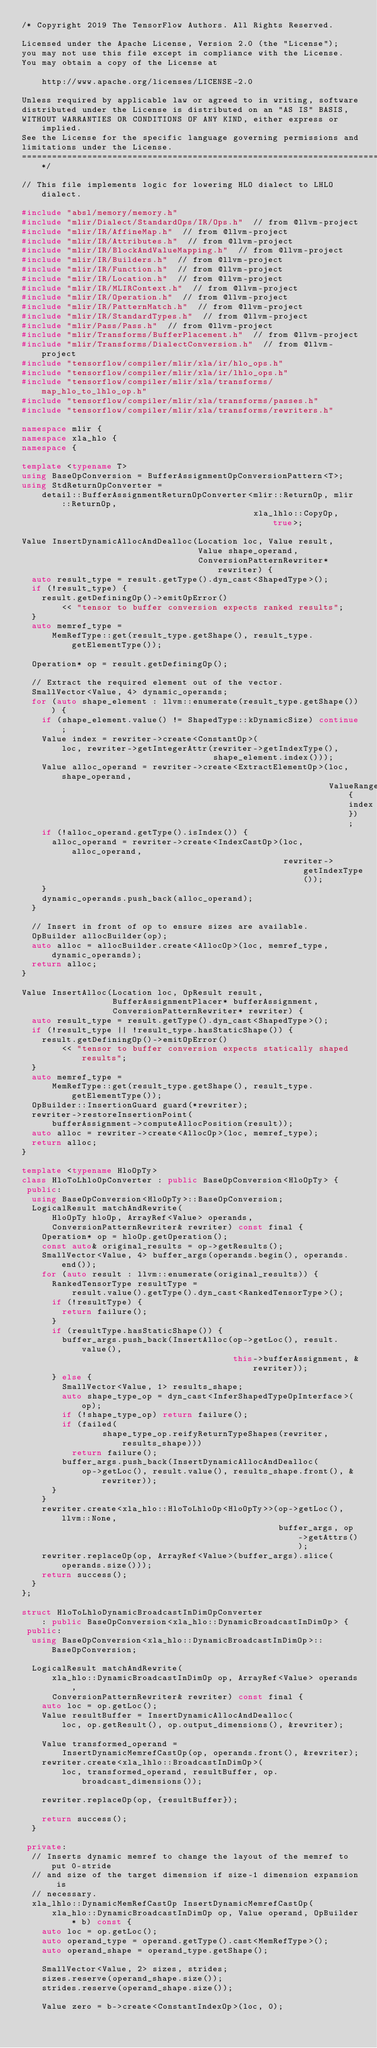<code> <loc_0><loc_0><loc_500><loc_500><_C++_>/* Copyright 2019 The TensorFlow Authors. All Rights Reserved.

Licensed under the Apache License, Version 2.0 (the "License");
you may not use this file except in compliance with the License.
You may obtain a copy of the License at

    http://www.apache.org/licenses/LICENSE-2.0

Unless required by applicable law or agreed to in writing, software
distributed under the License is distributed on an "AS IS" BASIS,
WITHOUT WARRANTIES OR CONDITIONS OF ANY KIND, either express or implied.
See the License for the specific language governing permissions and
limitations under the License.
==============================================================================*/

// This file implements logic for lowering HLO dialect to LHLO dialect.

#include "absl/memory/memory.h"
#include "mlir/Dialect/StandardOps/IR/Ops.h"  // from @llvm-project
#include "mlir/IR/AffineMap.h"  // from @llvm-project
#include "mlir/IR/Attributes.h"  // from @llvm-project
#include "mlir/IR/BlockAndValueMapping.h"  // from @llvm-project
#include "mlir/IR/Builders.h"  // from @llvm-project
#include "mlir/IR/Function.h"  // from @llvm-project
#include "mlir/IR/Location.h"  // from @llvm-project
#include "mlir/IR/MLIRContext.h"  // from @llvm-project
#include "mlir/IR/Operation.h"  // from @llvm-project
#include "mlir/IR/PatternMatch.h"  // from @llvm-project
#include "mlir/IR/StandardTypes.h"  // from @llvm-project
#include "mlir/Pass/Pass.h"  // from @llvm-project
#include "mlir/Transforms/BufferPlacement.h"  // from @llvm-project
#include "mlir/Transforms/DialectConversion.h"  // from @llvm-project
#include "tensorflow/compiler/mlir/xla/ir/hlo_ops.h"
#include "tensorflow/compiler/mlir/xla/ir/lhlo_ops.h"
#include "tensorflow/compiler/mlir/xla/transforms/map_hlo_to_lhlo_op.h"
#include "tensorflow/compiler/mlir/xla/transforms/passes.h"
#include "tensorflow/compiler/mlir/xla/transforms/rewriters.h"

namespace mlir {
namespace xla_hlo {
namespace {

template <typename T>
using BaseOpConversion = BufferAssignmentOpConversionPattern<T>;
using StdReturnOpConverter =
    detail::BufferAssignmentReturnOpConverter<mlir::ReturnOp, mlir::ReturnOp,
                                              xla_lhlo::CopyOp, true>;

Value InsertDynamicAllocAndDealloc(Location loc, Value result,
                                   Value shape_operand,
                                   ConversionPatternRewriter* rewriter) {
  auto result_type = result.getType().dyn_cast<ShapedType>();
  if (!result_type) {
    result.getDefiningOp()->emitOpError()
        << "tensor to buffer conversion expects ranked results";
  }
  auto memref_type =
      MemRefType::get(result_type.getShape(), result_type.getElementType());

  Operation* op = result.getDefiningOp();

  // Extract the required element out of the vector.
  SmallVector<Value, 4> dynamic_operands;
  for (auto shape_element : llvm::enumerate(result_type.getShape())) {
    if (shape_element.value() != ShapedType::kDynamicSize) continue;
    Value index = rewriter->create<ConstantOp>(
        loc, rewriter->getIntegerAttr(rewriter->getIndexType(),
                                      shape_element.index()));
    Value alloc_operand = rewriter->create<ExtractElementOp>(loc, shape_operand,
                                                             ValueRange{index});
    if (!alloc_operand.getType().isIndex()) {
      alloc_operand = rewriter->create<IndexCastOp>(loc, alloc_operand,
                                                    rewriter->getIndexType());
    }
    dynamic_operands.push_back(alloc_operand);
  }

  // Insert in front of op to ensure sizes are available.
  OpBuilder allocBuilder(op);
  auto alloc = allocBuilder.create<AllocOp>(loc, memref_type, dynamic_operands);
  return alloc;
}

Value InsertAlloc(Location loc, OpResult result,
                  BufferAssignmentPlacer* bufferAssignment,
                  ConversionPatternRewriter* rewriter) {
  auto result_type = result.getType().dyn_cast<ShapedType>();
  if (!result_type || !result_type.hasStaticShape()) {
    result.getDefiningOp()->emitOpError()
        << "tensor to buffer conversion expects statically shaped results";
  }
  auto memref_type =
      MemRefType::get(result_type.getShape(), result_type.getElementType());
  OpBuilder::InsertionGuard guard(*rewriter);
  rewriter->restoreInsertionPoint(
      bufferAssignment->computeAllocPosition(result));
  auto alloc = rewriter->create<AllocOp>(loc, memref_type);
  return alloc;
}

template <typename HloOpTy>
class HloToLhloOpConverter : public BaseOpConversion<HloOpTy> {
 public:
  using BaseOpConversion<HloOpTy>::BaseOpConversion;
  LogicalResult matchAndRewrite(
      HloOpTy hloOp, ArrayRef<Value> operands,
      ConversionPatternRewriter& rewriter) const final {
    Operation* op = hloOp.getOperation();
    const auto& original_results = op->getResults();
    SmallVector<Value, 4> buffer_args(operands.begin(), operands.end());
    for (auto result : llvm::enumerate(original_results)) {
      RankedTensorType resultType =
          result.value().getType().dyn_cast<RankedTensorType>();
      if (!resultType) {
        return failure();
      }
      if (resultType.hasStaticShape()) {
        buffer_args.push_back(InsertAlloc(op->getLoc(), result.value(),
                                          this->bufferAssignment, &rewriter));
      } else {
        SmallVector<Value, 1> results_shape;
        auto shape_type_op = dyn_cast<InferShapedTypeOpInterface>(op);
        if (!shape_type_op) return failure();
        if (failed(
                shape_type_op.reifyReturnTypeShapes(rewriter, results_shape)))
          return failure();
        buffer_args.push_back(InsertDynamicAllocAndDealloc(
            op->getLoc(), result.value(), results_shape.front(), &rewriter));
      }
    }
    rewriter.create<xla_hlo::HloToLhloOp<HloOpTy>>(op->getLoc(), llvm::None,
                                                   buffer_args, op->getAttrs());
    rewriter.replaceOp(op, ArrayRef<Value>(buffer_args).slice(operands.size()));
    return success();
  }
};

struct HloToLhloDynamicBroadcastInDimOpConverter
    : public BaseOpConversion<xla_hlo::DynamicBroadcastInDimOp> {
 public:
  using BaseOpConversion<xla_hlo::DynamicBroadcastInDimOp>::BaseOpConversion;

  LogicalResult matchAndRewrite(
      xla_hlo::DynamicBroadcastInDimOp op, ArrayRef<Value> operands,
      ConversionPatternRewriter& rewriter) const final {
    auto loc = op.getLoc();
    Value resultBuffer = InsertDynamicAllocAndDealloc(
        loc, op.getResult(), op.output_dimensions(), &rewriter);

    Value transformed_operand =
        InsertDynamicMemrefCastOp(op, operands.front(), &rewriter);
    rewriter.create<xla_lhlo::BroadcastInDimOp>(
        loc, transformed_operand, resultBuffer, op.broadcast_dimensions());

    rewriter.replaceOp(op, {resultBuffer});

    return success();
  }

 private:
  // Inserts dynamic memref to change the layout of the memref to put 0-stride
  // and size of the target dimension if size-1 dimension expansion is
  // necessary.
  xla_lhlo::DynamicMemRefCastOp InsertDynamicMemrefCastOp(
      xla_hlo::DynamicBroadcastInDimOp op, Value operand, OpBuilder* b) const {
    auto loc = op.getLoc();
    auto operand_type = operand.getType().cast<MemRefType>();
    auto operand_shape = operand_type.getShape();

    SmallVector<Value, 2> sizes, strides;
    sizes.reserve(operand_shape.size());
    strides.reserve(operand_shape.size());

    Value zero = b->create<ConstantIndexOp>(loc, 0);</code> 